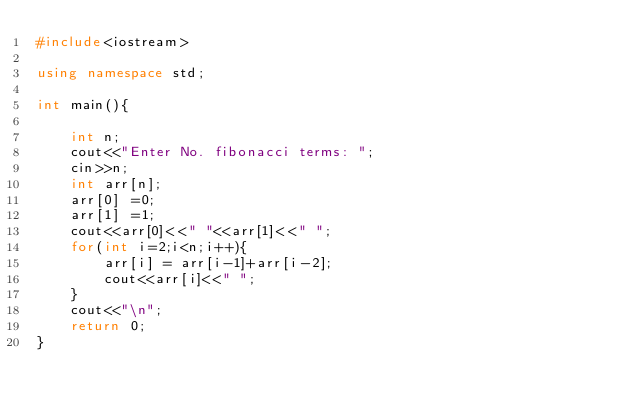<code> <loc_0><loc_0><loc_500><loc_500><_C++_>#include<iostream>

using namespace std;

int main(){

    int n;
    cout<<"Enter No. fibonacci terms: ";
    cin>>n;
    int arr[n];
    arr[0] =0;
    arr[1] =1;
    cout<<arr[0]<<" "<<arr[1]<<" ";
    for(int i=2;i<n;i++){
        arr[i] = arr[i-1]+arr[i-2];
        cout<<arr[i]<<" ";
    }
    cout<<"\n";
    return 0;
}</code> 